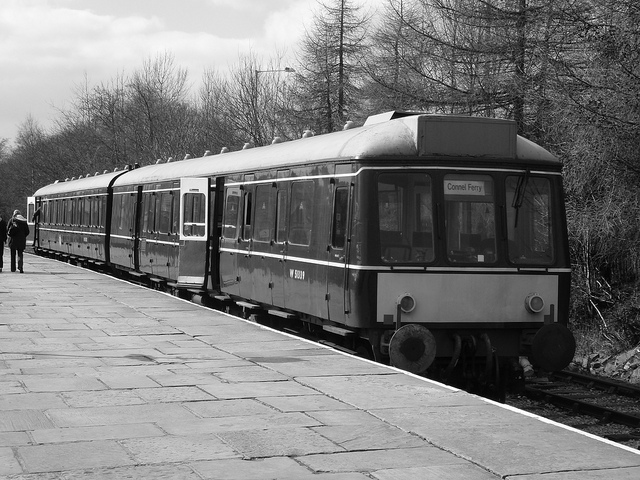Can you tell me more about the location where this photo was taken? Based on the natural surroundings and the platform design, the photo seems to have been taken at a rural or semi-rural train station. The mature trees and older platform suggest a location that has been in use for some decades, perhaps a heritage railway that has been preserved for historical interest or tourist purposes. 